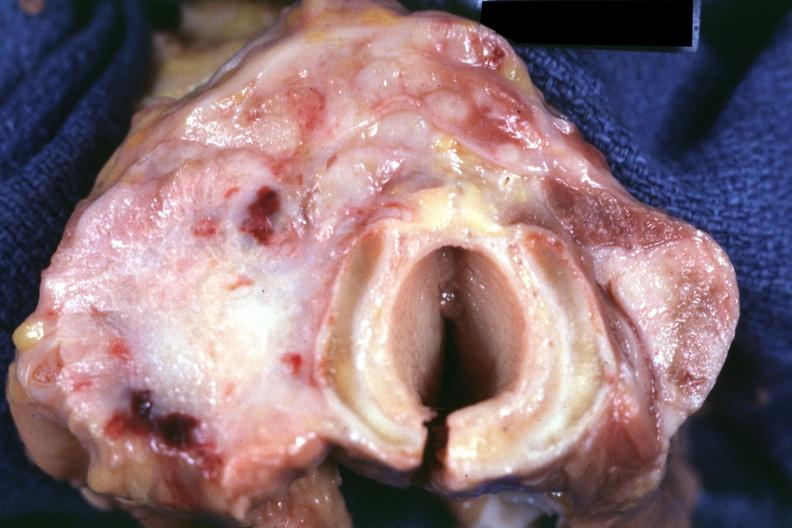s carcinoma had metastases to lungs, pleura, liver and regional nodes?
Answer the question using a single word or phrase. Yes 